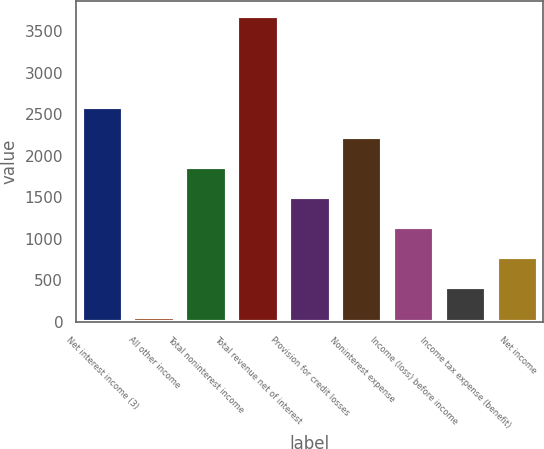<chart> <loc_0><loc_0><loc_500><loc_500><bar_chart><fcel>Net interest income (3)<fcel>All other income<fcel>Total noninterest income<fcel>Total revenue net of interest<fcel>Provision for credit losses<fcel>Noninterest expense<fcel>Income (loss) before income<fcel>Income tax expense (benefit)<fcel>Net income<nl><fcel>2591.5<fcel>54<fcel>1866.5<fcel>3679<fcel>1504<fcel>2229<fcel>1141.5<fcel>416.5<fcel>779<nl></chart> 